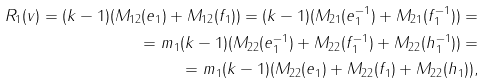<formula> <loc_0><loc_0><loc_500><loc_500>R _ { 1 } ( v ) = ( k - 1 ) ( M _ { 1 2 } ( e _ { 1 } ) + M _ { 1 2 } ( f _ { 1 } ) ) = ( k - 1 ) ( M _ { 2 1 } ( e _ { 1 } ^ { - 1 } ) + M _ { 2 1 } ( f _ { 1 } ^ { - 1 } ) ) = \\ = m _ { 1 } ( k - 1 ) ( M _ { 2 2 } ( e _ { 1 } ^ { - 1 } ) + M _ { 2 2 } ( f _ { 1 } ^ { - 1 } ) + M _ { 2 2 } ( h _ { 1 } ^ { - 1 } ) ) = \\ = m _ { 1 } ( k - 1 ) ( M _ { 2 2 } ( e _ { 1 } ) + M _ { 2 2 } ( f _ { 1 } ) + M _ { 2 2 } ( h _ { 1 } ) ) ,</formula> 